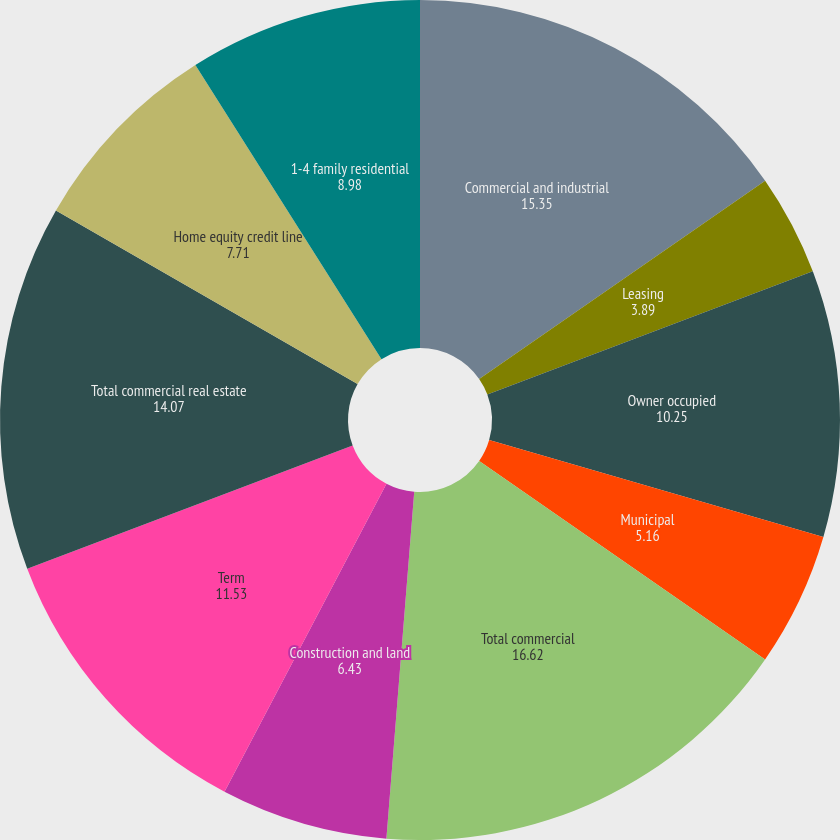Convert chart to OTSL. <chart><loc_0><loc_0><loc_500><loc_500><pie_chart><fcel>Commercial and industrial<fcel>Leasing<fcel>Owner occupied<fcel>Municipal<fcel>Total commercial<fcel>Construction and land<fcel>Term<fcel>Total commercial real estate<fcel>Home equity credit line<fcel>1-4 family residential<nl><fcel>15.35%<fcel>3.89%<fcel>10.25%<fcel>5.16%<fcel>16.62%<fcel>6.43%<fcel>11.53%<fcel>14.07%<fcel>7.71%<fcel>8.98%<nl></chart> 